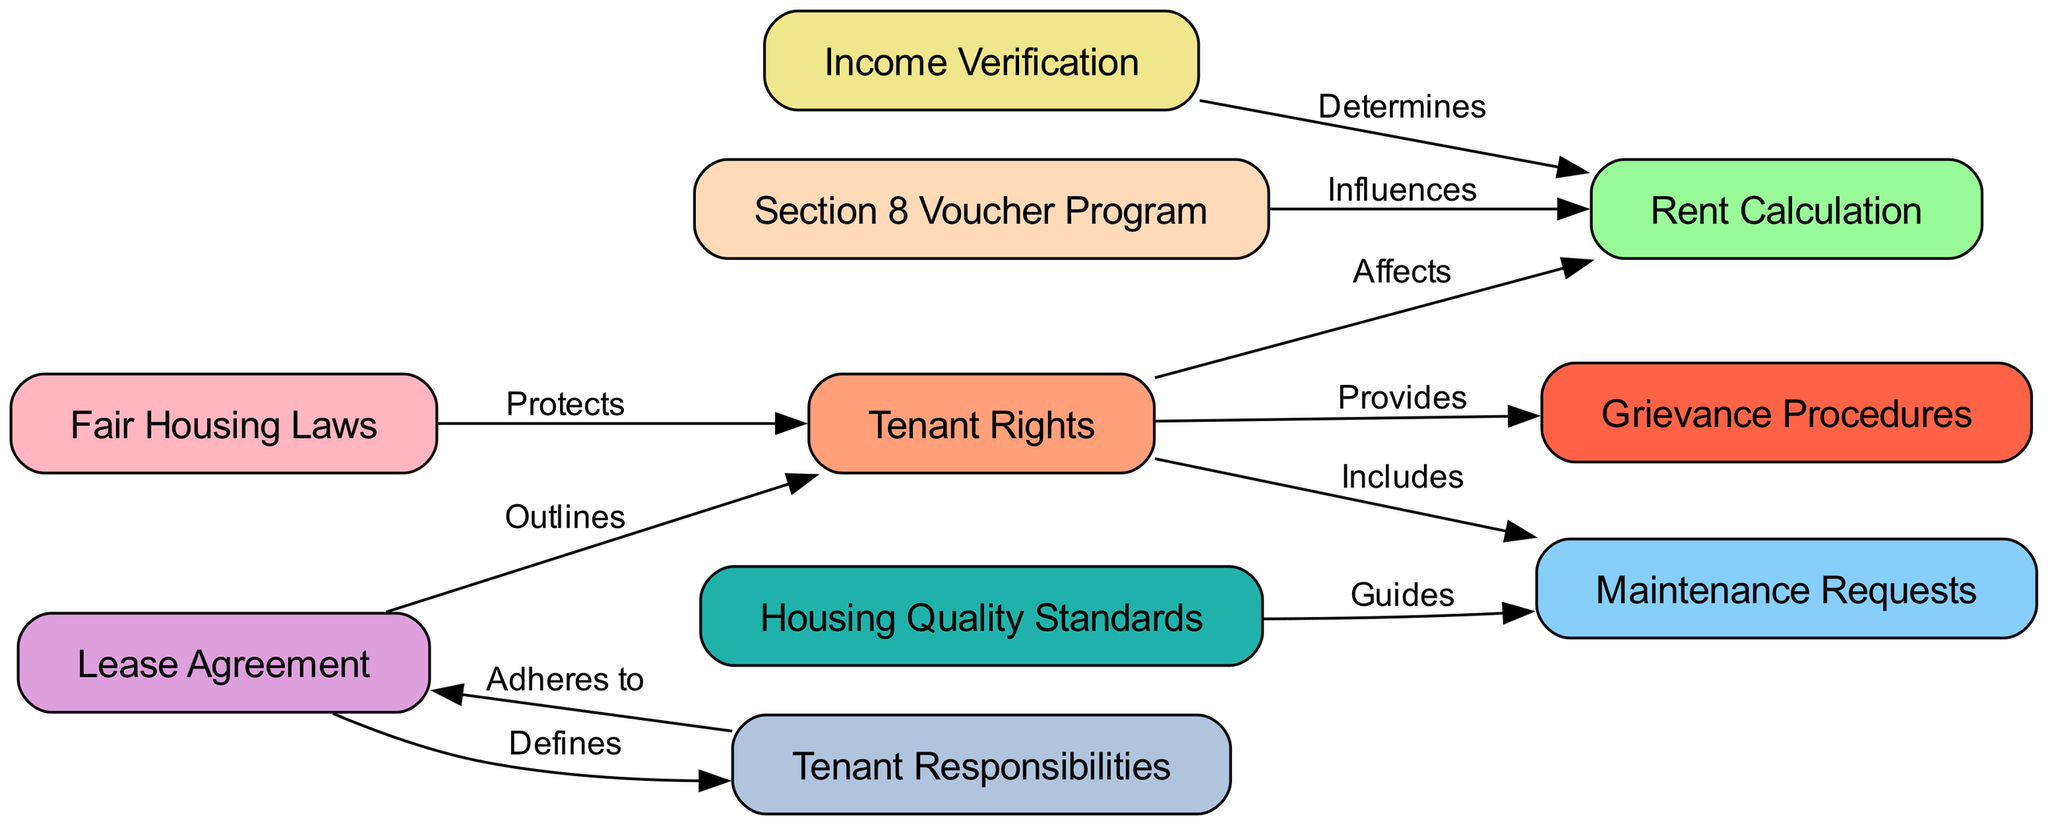What are the total number of nodes in the diagram? The nodes present in the diagram include: Tenant Rights, Rent Calculation, Maintenance Requests, Lease Agreement, Income Verification, Grievance Procedures, Housing Quality Standards, Fair Housing Laws, Tenant Responsibilities, and Section 8 Voucher Program. Counting these gives a total of 10 distinct nodes.
Answer: 10 What role does the Lease Agreement play in relation to Tenant Responsibilities? The Lease Agreement defines the Tenant Responsibilities. This is indicated by the edge directed from Lease Agreement to Tenant Responsibilities, labeled "Defines".
Answer: Defines Which node is directly influenced by the Section 8 Voucher Program? The diagram shows that the Section 8 Voucher Program influences Rent Calculation, as evidenced by the directed edge connecting these two nodes with the label "Influences".
Answer: Rent Calculation What does Fair Housing Laws do in respect to Tenant Rights? Fair Housing Laws protect Tenant Rights, demonstrated by the edge pointing from Fair Housing Laws to Tenant Rights, marked with the label "Protects".
Answer: Protects How do Housing Quality Standards relate to Maintenance Requests? Housing Quality Standards guide Maintenance Requests, shown by the directed edge from Housing Quality Standards to Maintenance Requests, labeled "Guides".
Answer: Guides What is the relationship between Income Verification and Rent Calculation? The edge from Income Verification to Rent Calculation indicates that Income Verification determines Rent Calculation, labeled "Determines". Thus, knowing the income affects how rent is calculated.
Answer: Determines Which node outlines the Tenant Rights? The Lease Agreement outlines the Tenant Rights, as indicated by the edge connecting Lease Agreement to Tenant Rights, described with the label "Outlines".
Answer: Outlines What type of procedures does Tenant Rights provide? Tenant Rights provides Grievance Procedures, evidenced by the directed edge from Tenant Rights to Grievance Procedures, labeled "Provides". This portrays that Tenant Rights include a mechanism for addressing grievances.
Answer: Provides What set of standards does Maintenance Requests follow? Maintenance Requests are guided by Housing Quality Standards, indicated by the directed edge from Housing Quality Standards to Maintenance Requests, labeled "Guides". This implies that requests for maintenance are informed by established quality standards.
Answer: Guides 